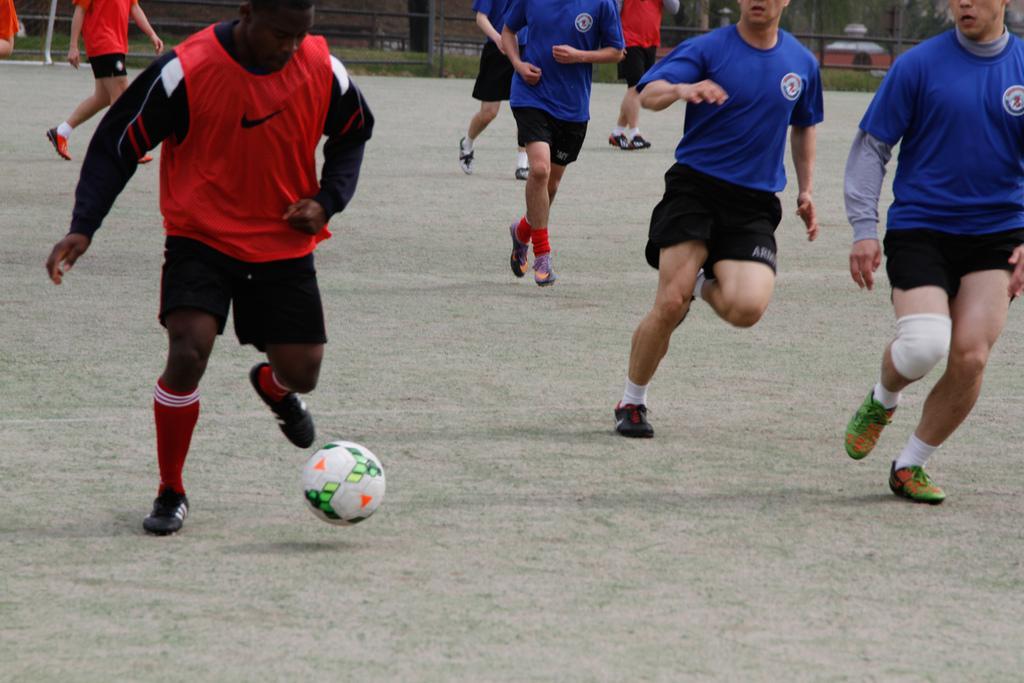Please provide a concise description of this image. This is a picture taken in the outdoor. This is a ground on the ground there are the people running. There are people in blue t shirt and red t shirt. The man in red t shirt running with a ball and the ball is in white color. Background of this people is a fencing. 